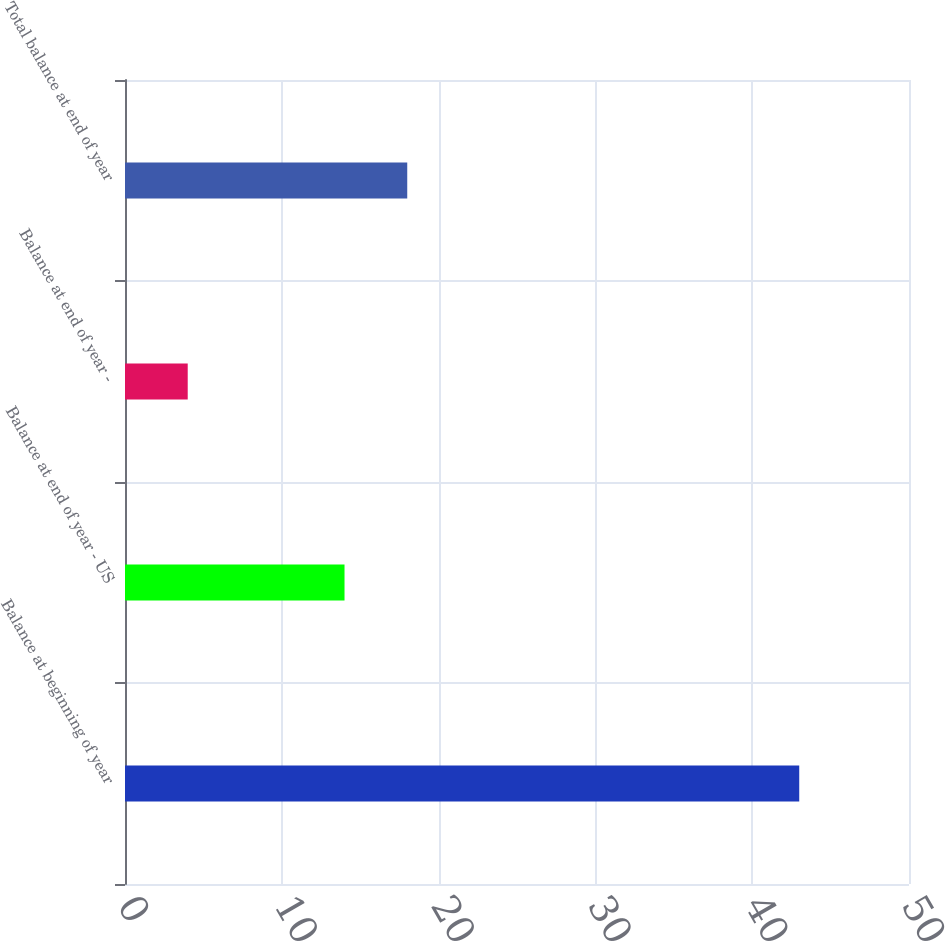Convert chart. <chart><loc_0><loc_0><loc_500><loc_500><bar_chart><fcel>Balance at beginning of year<fcel>Balance at end of year - US<fcel>Balance at end of year -<fcel>Total balance at end of year<nl><fcel>43<fcel>14<fcel>4<fcel>18<nl></chart> 